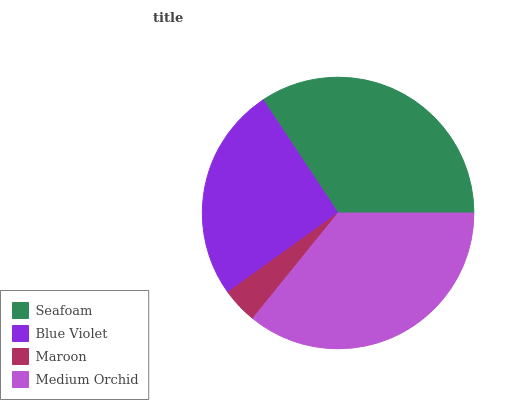Is Maroon the minimum?
Answer yes or no. Yes. Is Medium Orchid the maximum?
Answer yes or no. Yes. Is Blue Violet the minimum?
Answer yes or no. No. Is Blue Violet the maximum?
Answer yes or no. No. Is Seafoam greater than Blue Violet?
Answer yes or no. Yes. Is Blue Violet less than Seafoam?
Answer yes or no. Yes. Is Blue Violet greater than Seafoam?
Answer yes or no. No. Is Seafoam less than Blue Violet?
Answer yes or no. No. Is Seafoam the high median?
Answer yes or no. Yes. Is Blue Violet the low median?
Answer yes or no. Yes. Is Blue Violet the high median?
Answer yes or no. No. Is Medium Orchid the low median?
Answer yes or no. No. 